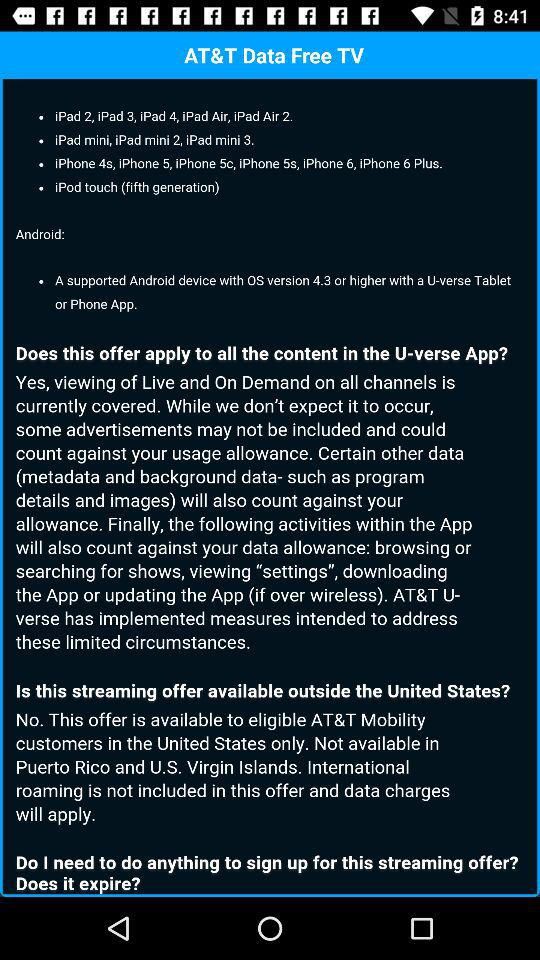How many iPad minis are there? There are 3 ipad minis. 